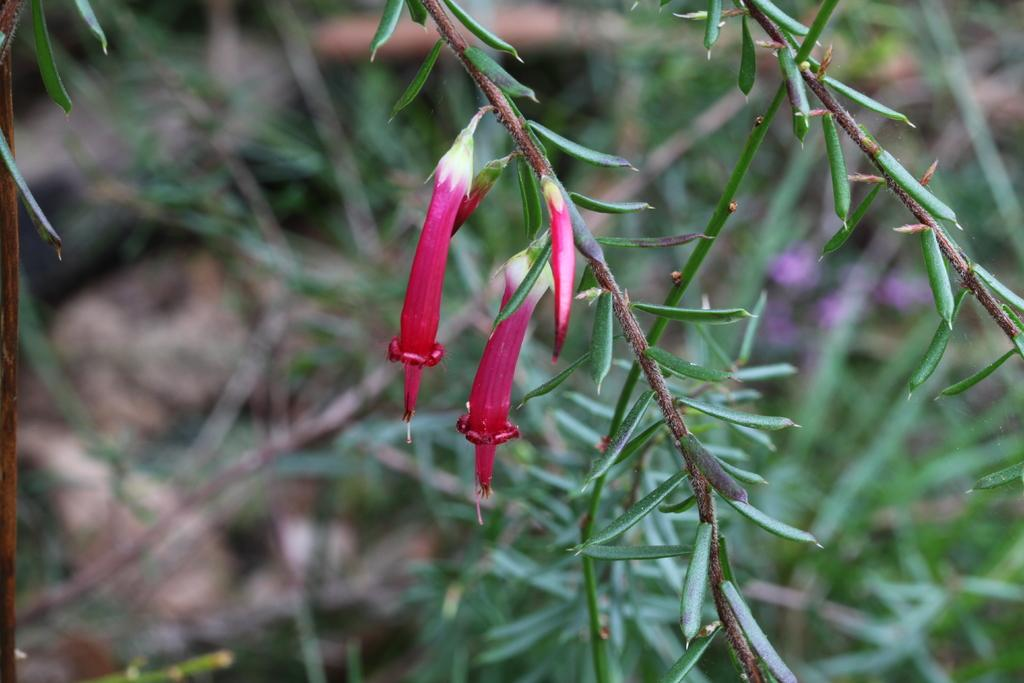What type of flowers can be seen on the plant in the image? There are red flowers on a plant in the image. What is the current hour according to the governor's map in the image? There is no governor or map present in the image; it only features red flowers on a plant. 